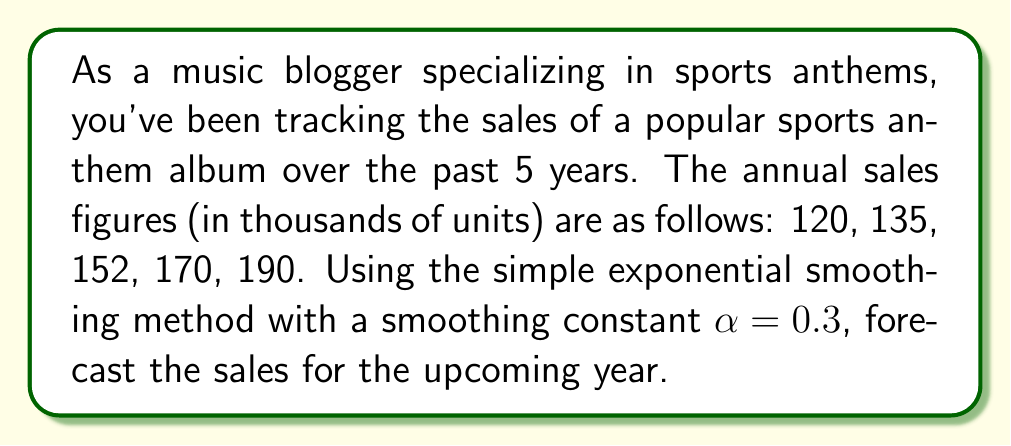Show me your answer to this math problem. To forecast future sales using the simple exponential smoothing method, we follow these steps:

1) The formula for simple exponential smoothing is:

   $$F_{t+1} = \alpha Y_t + (1-\alpha)F_t$$

   Where:
   $F_{t+1}$ is the forecast for the next period
   $\alpha$ is the smoothing constant (given as 0.3)
   $Y_t$ is the actual value at time t
   $F_t$ is the forecast for the current period

2) We start by setting the initial forecast ($F_1$) equal to the first observed value:

   $F_1 = 120$

3) Now we calculate the forecasts for each subsequent year:

   For year 2: $F_2 = 0.3(120) + 0.7(120) = 120$
   For year 3: $F_3 = 0.3(135) + 0.7(120) = 124.5$
   For year 4: $F_4 = 0.3(152) + 0.7(124.5) = 132.75$
   For year 5: $F_5 = 0.3(170) + 0.7(132.75) = 144.425$

4) Finally, we can calculate the forecast for year 6:

   $F_6 = 0.3(190) + 0.7(144.425) = 158.0975$

Therefore, the forecast for the upcoming year (year 6) is approximately 158,098 units.
Answer: 158,098 units 